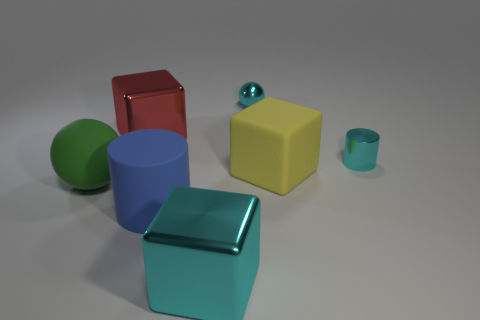Subtract all large metal blocks. How many blocks are left? 1 Subtract all cyan balls. How many balls are left? 1 Subtract 1 spheres. How many spheres are left? 1 Add 2 rubber cylinders. How many objects exist? 9 Subtract all balls. How many objects are left? 5 Subtract all big blue rubber objects. Subtract all matte cylinders. How many objects are left? 5 Add 7 big green objects. How many big green objects are left? 8 Add 5 large brown shiny objects. How many large brown shiny objects exist? 5 Subtract 0 purple spheres. How many objects are left? 7 Subtract all red blocks. Subtract all brown spheres. How many blocks are left? 2 